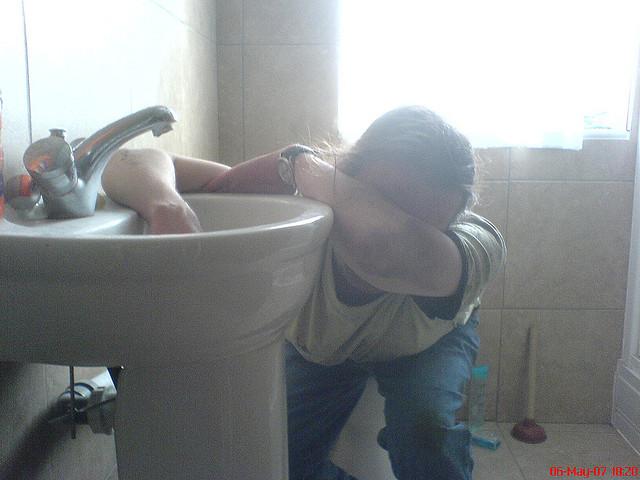Is this person sick?
Keep it brief. Yes. Is the girl laughing?
Keep it brief. No. What is the person doing?
Quick response, please. Fixing sink. 